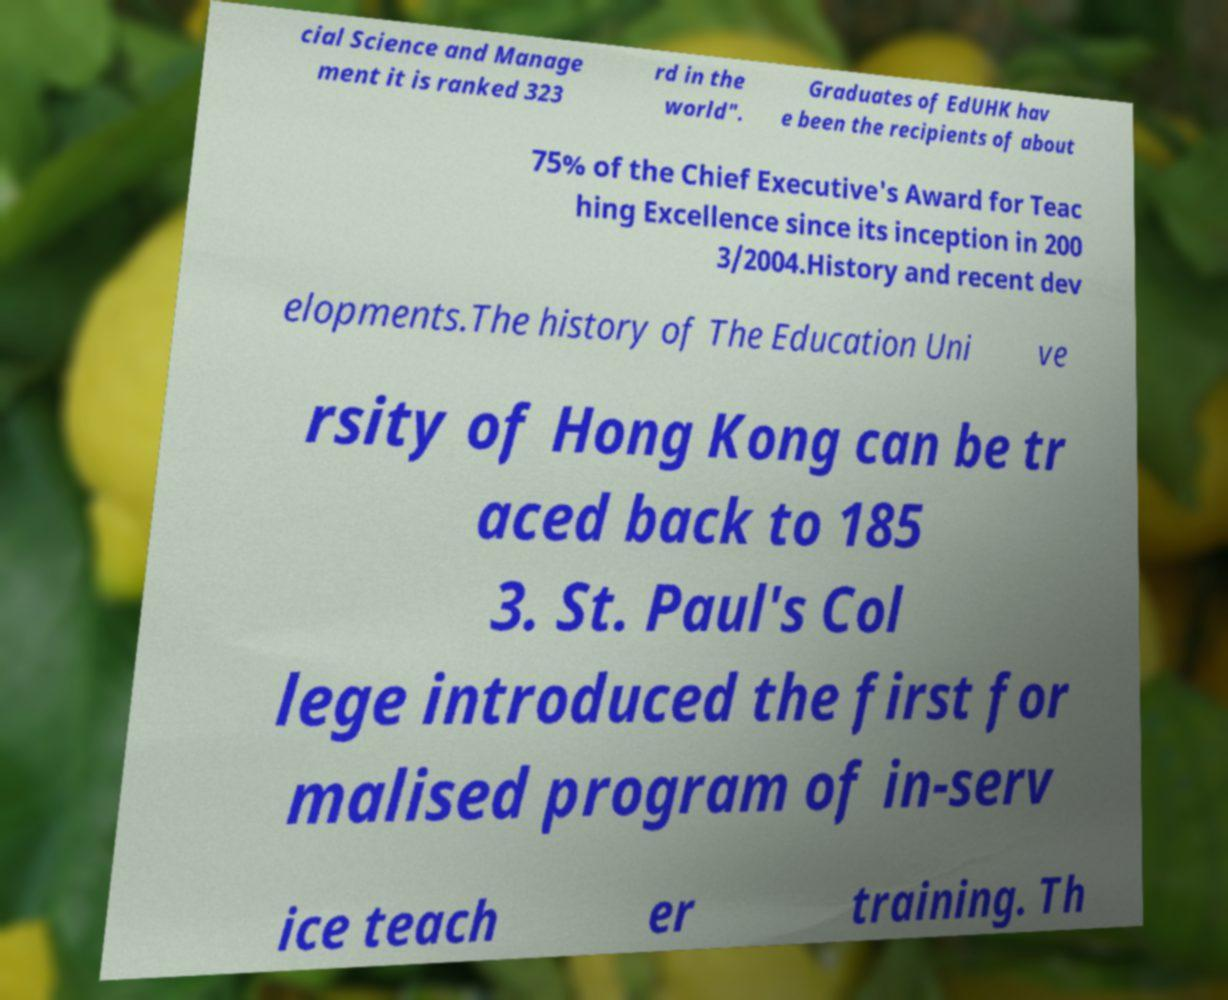Could you assist in decoding the text presented in this image and type it out clearly? cial Science and Manage ment it is ranked 323 rd in the world". Graduates of EdUHK hav e been the recipients of about 75% of the Chief Executive's Award for Teac hing Excellence since its inception in 200 3/2004.History and recent dev elopments.The history of The Education Uni ve rsity of Hong Kong can be tr aced back to 185 3. St. Paul's Col lege introduced the first for malised program of in-serv ice teach er training. Th 